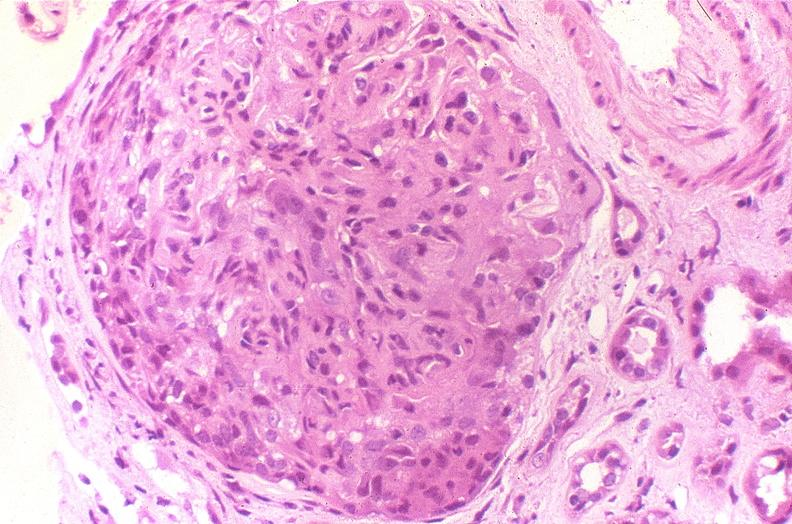s urinary present?
Answer the question using a single word or phrase. Yes 